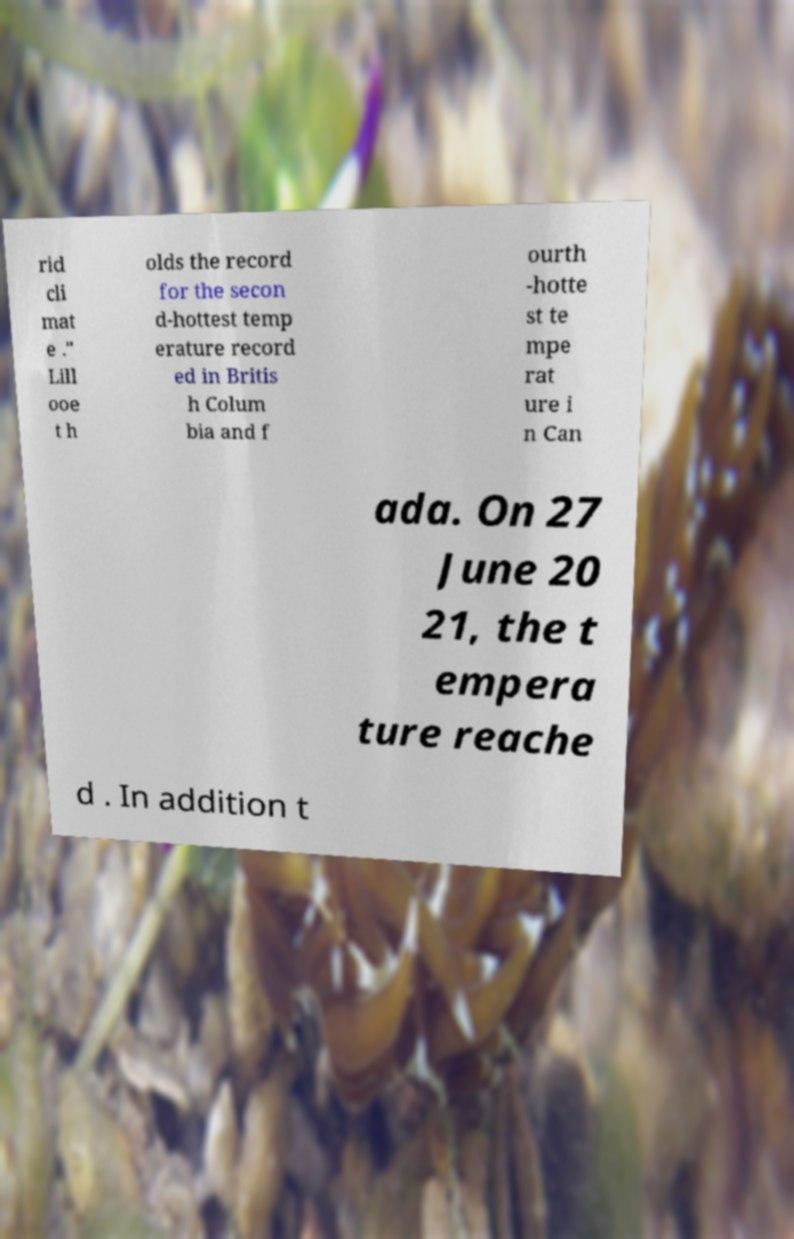Please read and relay the text visible in this image. What does it say? rid cli mat e ." Lill ooe t h olds the record for the secon d-hottest temp erature record ed in Britis h Colum bia and f ourth -hotte st te mpe rat ure i n Can ada. On 27 June 20 21, the t empera ture reache d . In addition t 